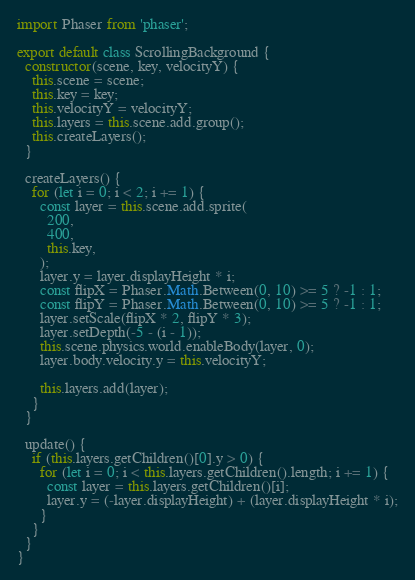Convert code to text. <code><loc_0><loc_0><loc_500><loc_500><_JavaScript_>import Phaser from 'phaser';

export default class ScrollingBackground {
  constructor(scene, key, velocityY) {
    this.scene = scene;
    this.key = key;
    this.velocityY = velocityY;
    this.layers = this.scene.add.group();
    this.createLayers();
  }

  createLayers() {
    for (let i = 0; i < 2; i += 1) {
      const layer = this.scene.add.sprite(
        200,
        400,
        this.key,
      );
      layer.y = layer.displayHeight * i;
      const flipX = Phaser.Math.Between(0, 10) >= 5 ? -1 : 1;
      const flipY = Phaser.Math.Between(0, 10) >= 5 ? -1 : 1;
      layer.setScale(flipX * 2, flipY * 3);
      layer.setDepth(-5 - (i - 1));
      this.scene.physics.world.enableBody(layer, 0);
      layer.body.velocity.y = this.velocityY;

      this.layers.add(layer);
    }
  }

  update() {
    if (this.layers.getChildren()[0].y > 0) {
      for (let i = 0; i < this.layers.getChildren().length; i += 1) {
        const layer = this.layers.getChildren()[i];
        layer.y = (-layer.displayHeight) + (layer.displayHeight * i);
      }
    }
  }
}</code> 